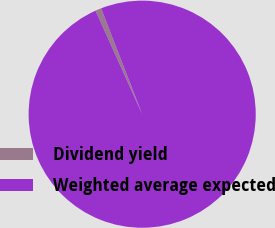Convert chart to OTSL. <chart><loc_0><loc_0><loc_500><loc_500><pie_chart><fcel>Dividend yield<fcel>Weighted average expected<nl><fcel>0.84%<fcel>99.16%<nl></chart> 